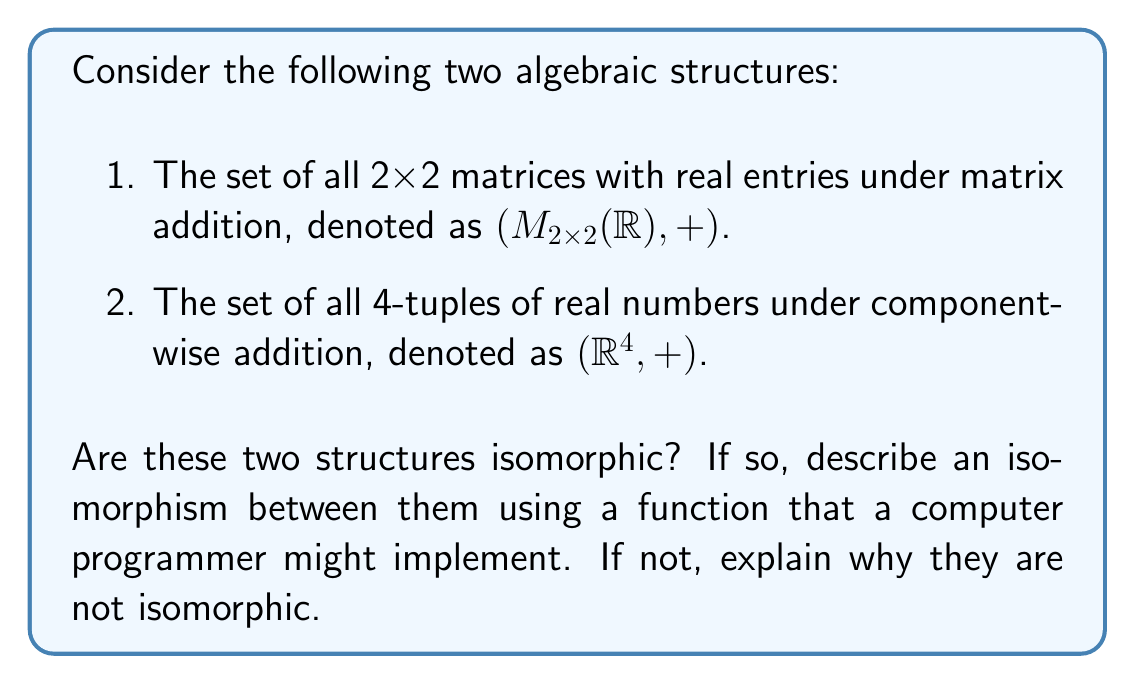Could you help me with this problem? To determine if these structures are isomorphic, we need to find a bijective homomorphism between them or prove that no such function exists. Let's approach this step-by-step:

1. First, let's consider the properties of both structures:
   - Both are abelian groups under addition.
   - Both have the same number of elements (uncountably infinite).
   - Both are vector spaces over $\mathbb{R}$ with dimension 4.

2. These similarities suggest that an isomorphism might exist. Let's try to construct one:

3. Define a function $f: M_{2x2}(\mathbb{R}) \rightarrow \mathbb{R}^4$ as follows:

   For a matrix $A = \begin{pmatrix} a & b \\ c & d \end{pmatrix}$,
   let $f(A) = (a, b, c, d)$

4. This function maps each 2x2 matrix to a 4-tuple of its entries.

5. To prove this is an isomorphism, we need to show it's bijective and preserves the group operation (addition):

   a) Bijective:
      - Injective: Different matrices map to different 4-tuples.
      - Surjective: Every 4-tuple corresponds to a unique 2x2 matrix.

   b) Preserves addition:
      For matrices $A = \begin{pmatrix} a_1 & b_1 \\ c_1 & d_1 \end{pmatrix}$ and $B = \begin{pmatrix} a_2 & b_2 \\ c_2 & d_2 \end{pmatrix}$,
      
      $f(A + B) = f(\begin{pmatrix} a_1+a_2 & b_1+b_2 \\ c_1+c_2 & d_1+d_2 \end{pmatrix}) = (a_1+a_2, b_1+b_2, c_1+c_2, d_1+d_2)$
      
      $f(A) + f(B) = (a_1, b_1, c_1, d_1) + (a_2, b_2, c_2, d_2) = (a_1+a_2, b_1+b_2, c_1+c_2, d_1+d_2)$

      Therefore, $f(A + B) = f(A) + f(B)$

6. From a programmer's perspective, this isomorphism can be implemented as a function that takes a 2x2 matrix as input and returns a 4-tuple, or vice versa.
Answer: Yes, the structures $(M_{2x2}(\mathbb{R}), +)$ and $(\mathbb{R}^4, +)$ are isomorphic. An isomorphism $f: M_{2x2}(\mathbb{R}) \rightarrow \mathbb{R}^4$ can be defined as $f(\begin{pmatrix} a & b \\ c & d \end{pmatrix}) = (a, b, c, d)$ for any 2x2 matrix $\begin{pmatrix} a & b \\ c & d \end{pmatrix}$. 